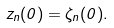Convert formula to latex. <formula><loc_0><loc_0><loc_500><loc_500>z _ { n } ( 0 ) = \zeta _ { n } ( 0 ) .</formula> 